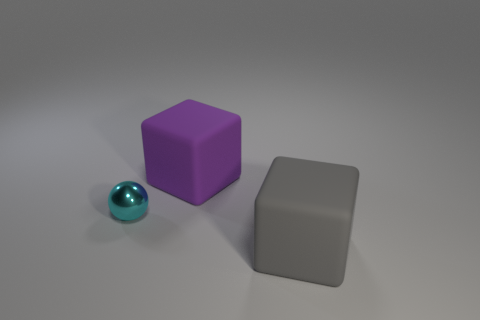Are there any other things that are the same material as the cyan ball?
Provide a short and direct response. No. Do the cyan metallic thing behind the gray rubber block and the rubber block that is left of the big gray cube have the same size?
Ensure brevity in your answer.  No. The object in front of the tiny ball is what color?
Provide a succinct answer. Gray. There is a gray rubber thing; is its size the same as the matte block that is to the left of the large gray rubber thing?
Your answer should be compact. Yes. How big is the matte object behind the matte object in front of the big cube that is behind the big gray object?
Give a very brief answer. Large. There is a tiny cyan metallic sphere; what number of big purple rubber blocks are on the left side of it?
Ensure brevity in your answer.  0. There is a block that is right of the large matte cube behind the gray rubber thing; what is its material?
Keep it short and to the point. Rubber. Are there any other things that are the same size as the purple rubber object?
Provide a short and direct response. Yes. Is the gray rubber object the same size as the purple object?
Provide a succinct answer. Yes. How many things are balls that are on the left side of the gray thing or cubes that are behind the tiny cyan sphere?
Your response must be concise. 2. 